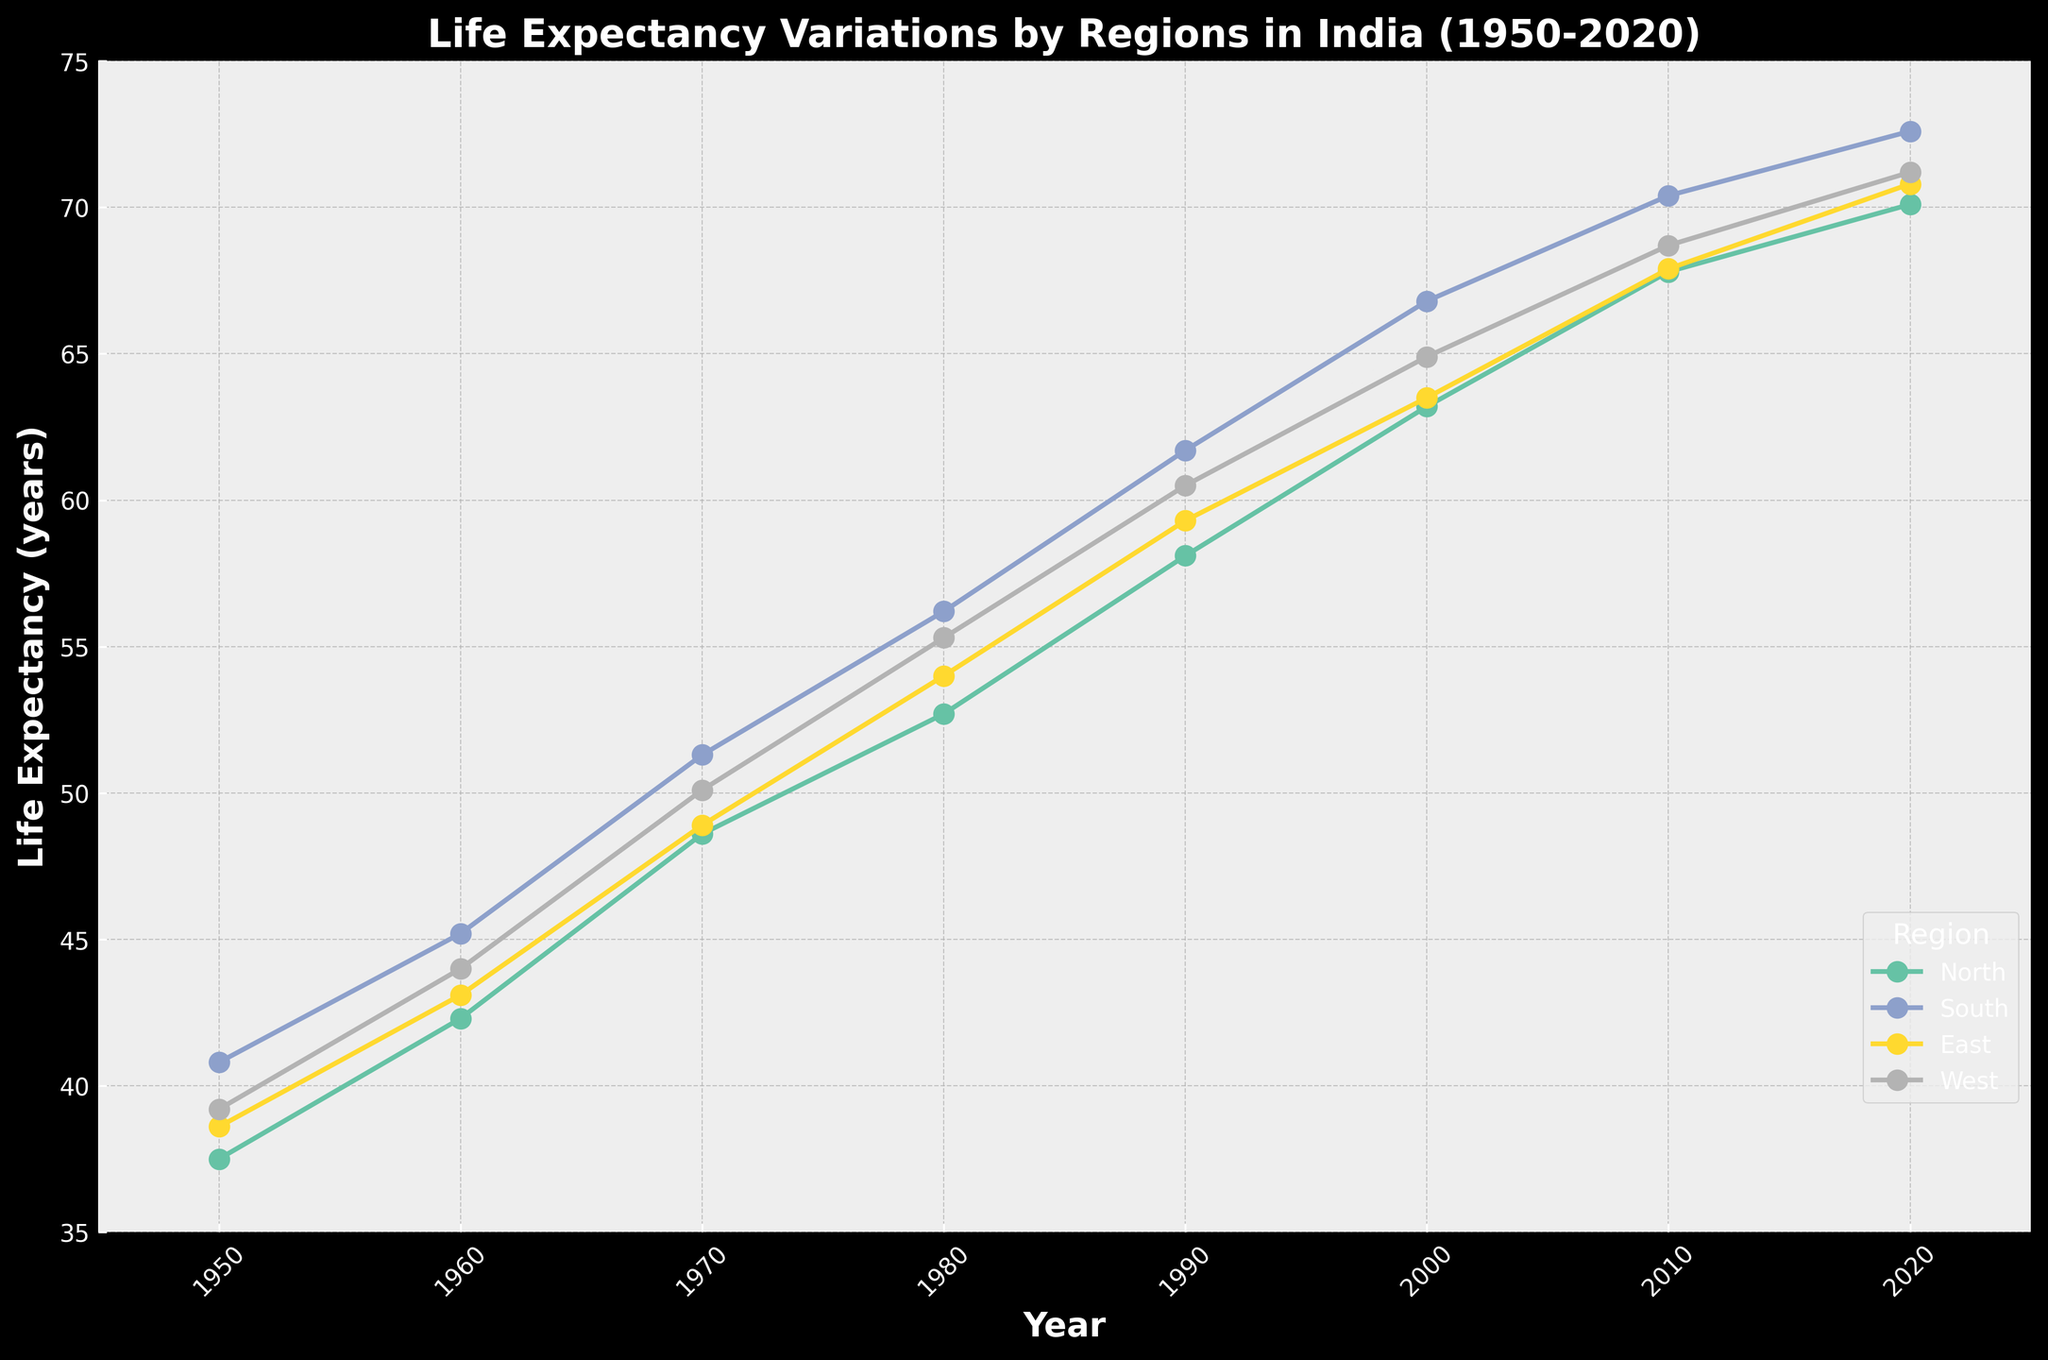How many regions are represented in the figure? By counting the number of distinct lines with different colors and labels, we can see that there are 4 regions represented: North, South, East, and West.
Answer: 4 What is the life expectancy in the North region in the year 2000? By locating the point corresponding to the year 2000 on the line representing the North region, we see that the life expectancy is 63.2 years.
Answer: 63.2 Which region had the highest life expectancy in 2020? By locating the points for the year 2020 across all regions, the South region has the highest point at 72.6 years.
Answer: South What is the difference in life expectancy between the East and West regions in 1980? By finding the points for the year 1980 for both East (54.0 years) and West (55.3 years), the difference is 55.3 - 54.0 = 1.3 years.
Answer: 1.3 Which region had the lowest life expectancy in 1950? By comparing the points for the year 1950 across all regions, the North region had the lowest life expectancy at 37.5 years.
Answer: North How much did the life expectancy in the South region increase from 1950 to 2020? By subtracting the life expectancy in 1950 (40.8 years) from that in 2020 (72.6 years), the increase is 72.6 - 40.8 = 31.8 years.
Answer: 31.8 What is the average life expectancy for the West region over the displayed period? By adding up the life expectancy values for the West region (39.2, 44.0, 50.1, 55.3, 60.5, 64.9, 68.7, 71.2) and dividing by 8, (39.2 + 44.0 + 50.1 + 55.3 + 60.5 + 64.9 + 68.7 + 71.2) / 8 = 56.74 years.
Answer: 56.74 Which decade saw the greatest increase in life expectancy for the North region? By calculating the difference in life expectancy for each decade: 1950-1960 (42.3-37.5 = 4.8), 1960-1970 (48.6-42.3 = 6.3), 1970-1980 (52.7-48.6 = 4.1), 1980-1990 (58.1-52.7 = 5.4), 1990-2000 (63.2-58.1 = 5.1), 2000-2010 (67.8-63.2 = 4.6), 2010-2020 (70.1-67.8 = 2.3), the 1960-1970 decade has the greatest increase at 6.3 years.
Answer: 1960-1970 